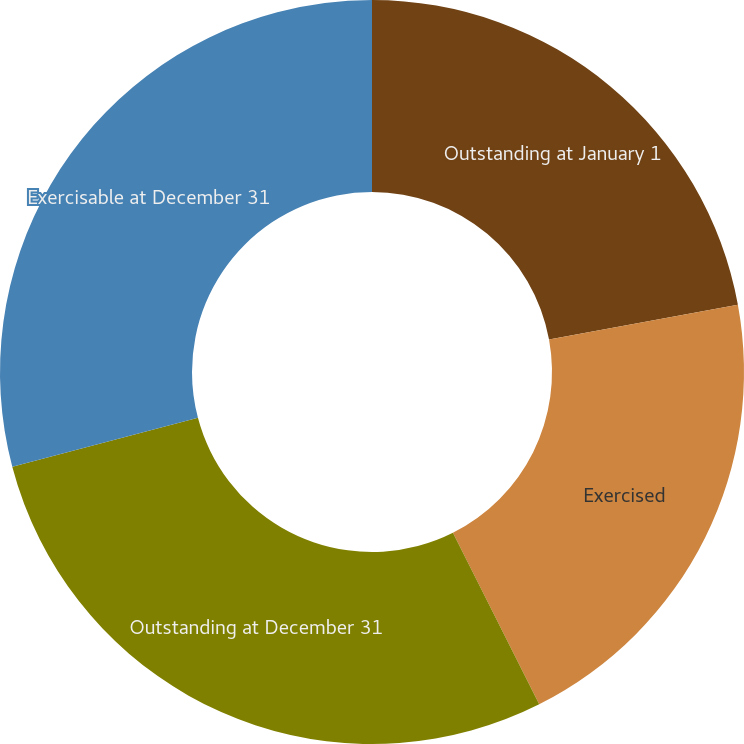Convert chart. <chart><loc_0><loc_0><loc_500><loc_500><pie_chart><fcel>Outstanding at January 1<fcel>Exercised<fcel>Outstanding at December 31<fcel>Exercisable at December 31<nl><fcel>22.11%<fcel>20.47%<fcel>28.32%<fcel>29.1%<nl></chart> 